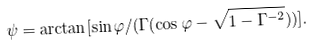Convert formula to latex. <formula><loc_0><loc_0><loc_500><loc_500>\psi = \arctan [ \sin \varphi / ( \Gamma ( \cos \varphi - \sqrt { 1 - \Gamma ^ { - 2 } } ) ) ] .</formula> 